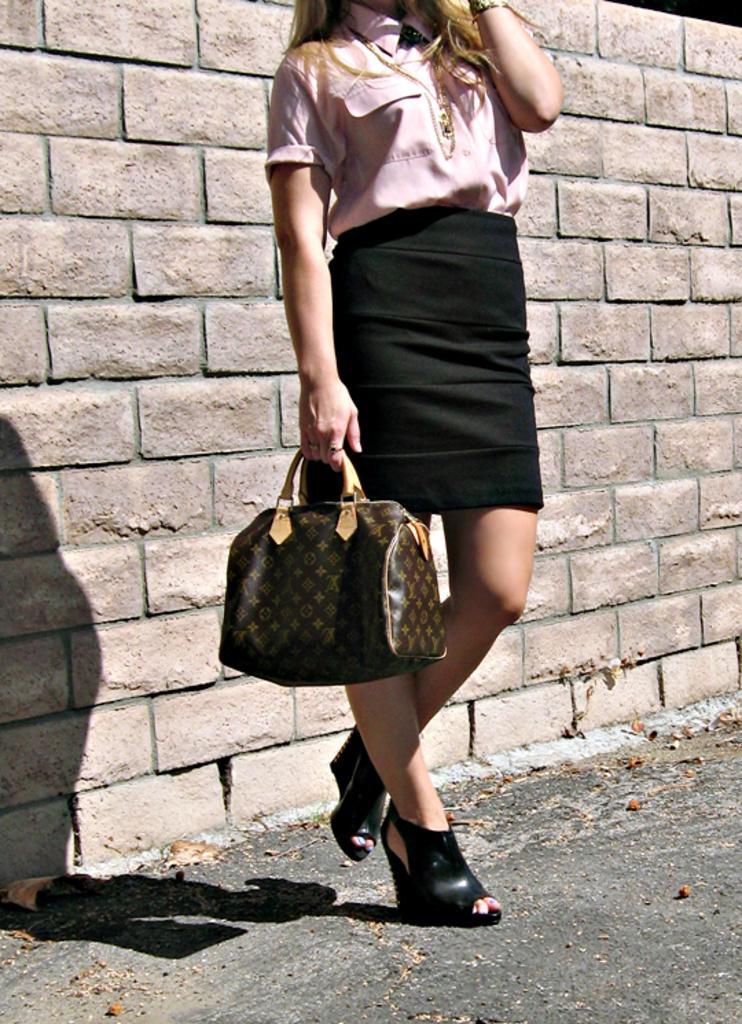Describe this image in one or two sentences. In this picture we can see a woman who is holding a bag with her hands. This is road and there is a wall. 